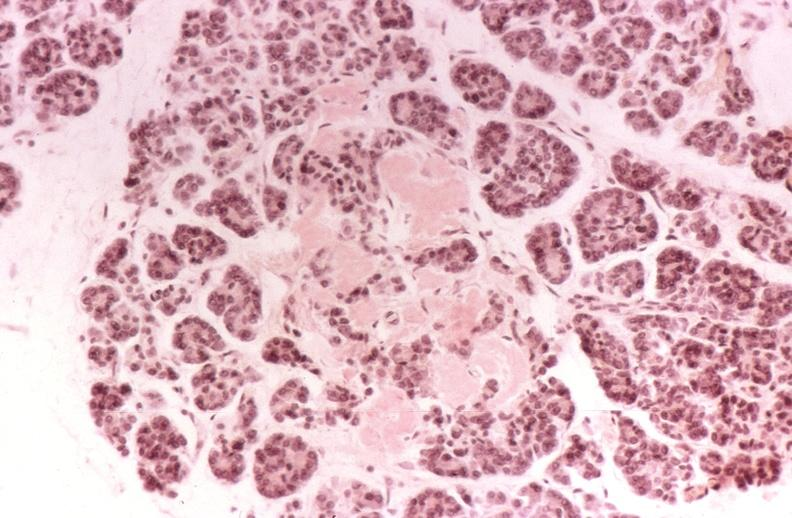s pancreas present?
Answer the question using a single word or phrase. Yes 